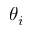Convert formula to latex. <formula><loc_0><loc_0><loc_500><loc_500>\theta _ { i }</formula> 